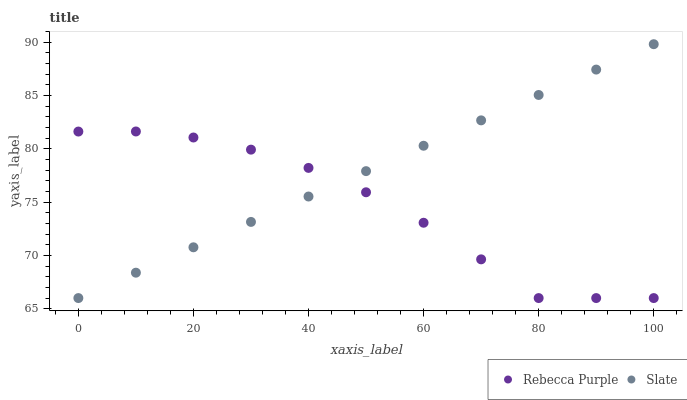Does Rebecca Purple have the minimum area under the curve?
Answer yes or no. Yes. Does Slate have the maximum area under the curve?
Answer yes or no. Yes. Does Rebecca Purple have the maximum area under the curve?
Answer yes or no. No. Is Slate the smoothest?
Answer yes or no. Yes. Is Rebecca Purple the roughest?
Answer yes or no. Yes. Is Rebecca Purple the smoothest?
Answer yes or no. No. Does Slate have the lowest value?
Answer yes or no. Yes. Does Slate have the highest value?
Answer yes or no. Yes. Does Rebecca Purple have the highest value?
Answer yes or no. No. Does Slate intersect Rebecca Purple?
Answer yes or no. Yes. Is Slate less than Rebecca Purple?
Answer yes or no. No. Is Slate greater than Rebecca Purple?
Answer yes or no. No. 